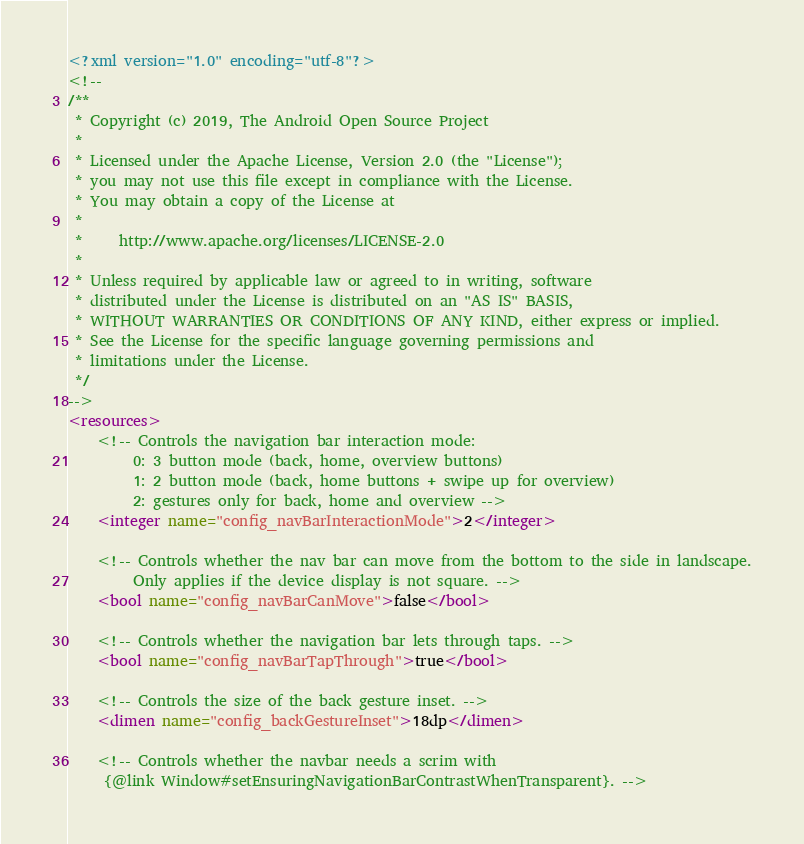Convert code to text. <code><loc_0><loc_0><loc_500><loc_500><_XML_><?xml version="1.0" encoding="utf-8"?>
<!--
/**
 * Copyright (c) 2019, The Android Open Source Project
 *
 * Licensed under the Apache License, Version 2.0 (the "License");
 * you may not use this file except in compliance with the License.
 * You may obtain a copy of the License at
 *
 *     http://www.apache.org/licenses/LICENSE-2.0
 *
 * Unless required by applicable law or agreed to in writing, software
 * distributed under the License is distributed on an "AS IS" BASIS,
 * WITHOUT WARRANTIES OR CONDITIONS OF ANY KIND, either express or implied.
 * See the License for the specific language governing permissions and
 * limitations under the License.
 */
-->
<resources>
    <!-- Controls the navigation bar interaction mode:
         0: 3 button mode (back, home, overview buttons)
         1: 2 button mode (back, home buttons + swipe up for overview)
         2: gestures only for back, home and overview -->
    <integer name="config_navBarInteractionMode">2</integer>

    <!-- Controls whether the nav bar can move from the bottom to the side in landscape.
         Only applies if the device display is not square. -->
    <bool name="config_navBarCanMove">false</bool>

    <!-- Controls whether the navigation bar lets through taps. -->
    <bool name="config_navBarTapThrough">true</bool>

    <!-- Controls the size of the back gesture inset. -->
    <dimen name="config_backGestureInset">18dp</dimen>

    <!-- Controls whether the navbar needs a scrim with
     {@link Window#setEnsuringNavigationBarContrastWhenTransparent}. --></code> 